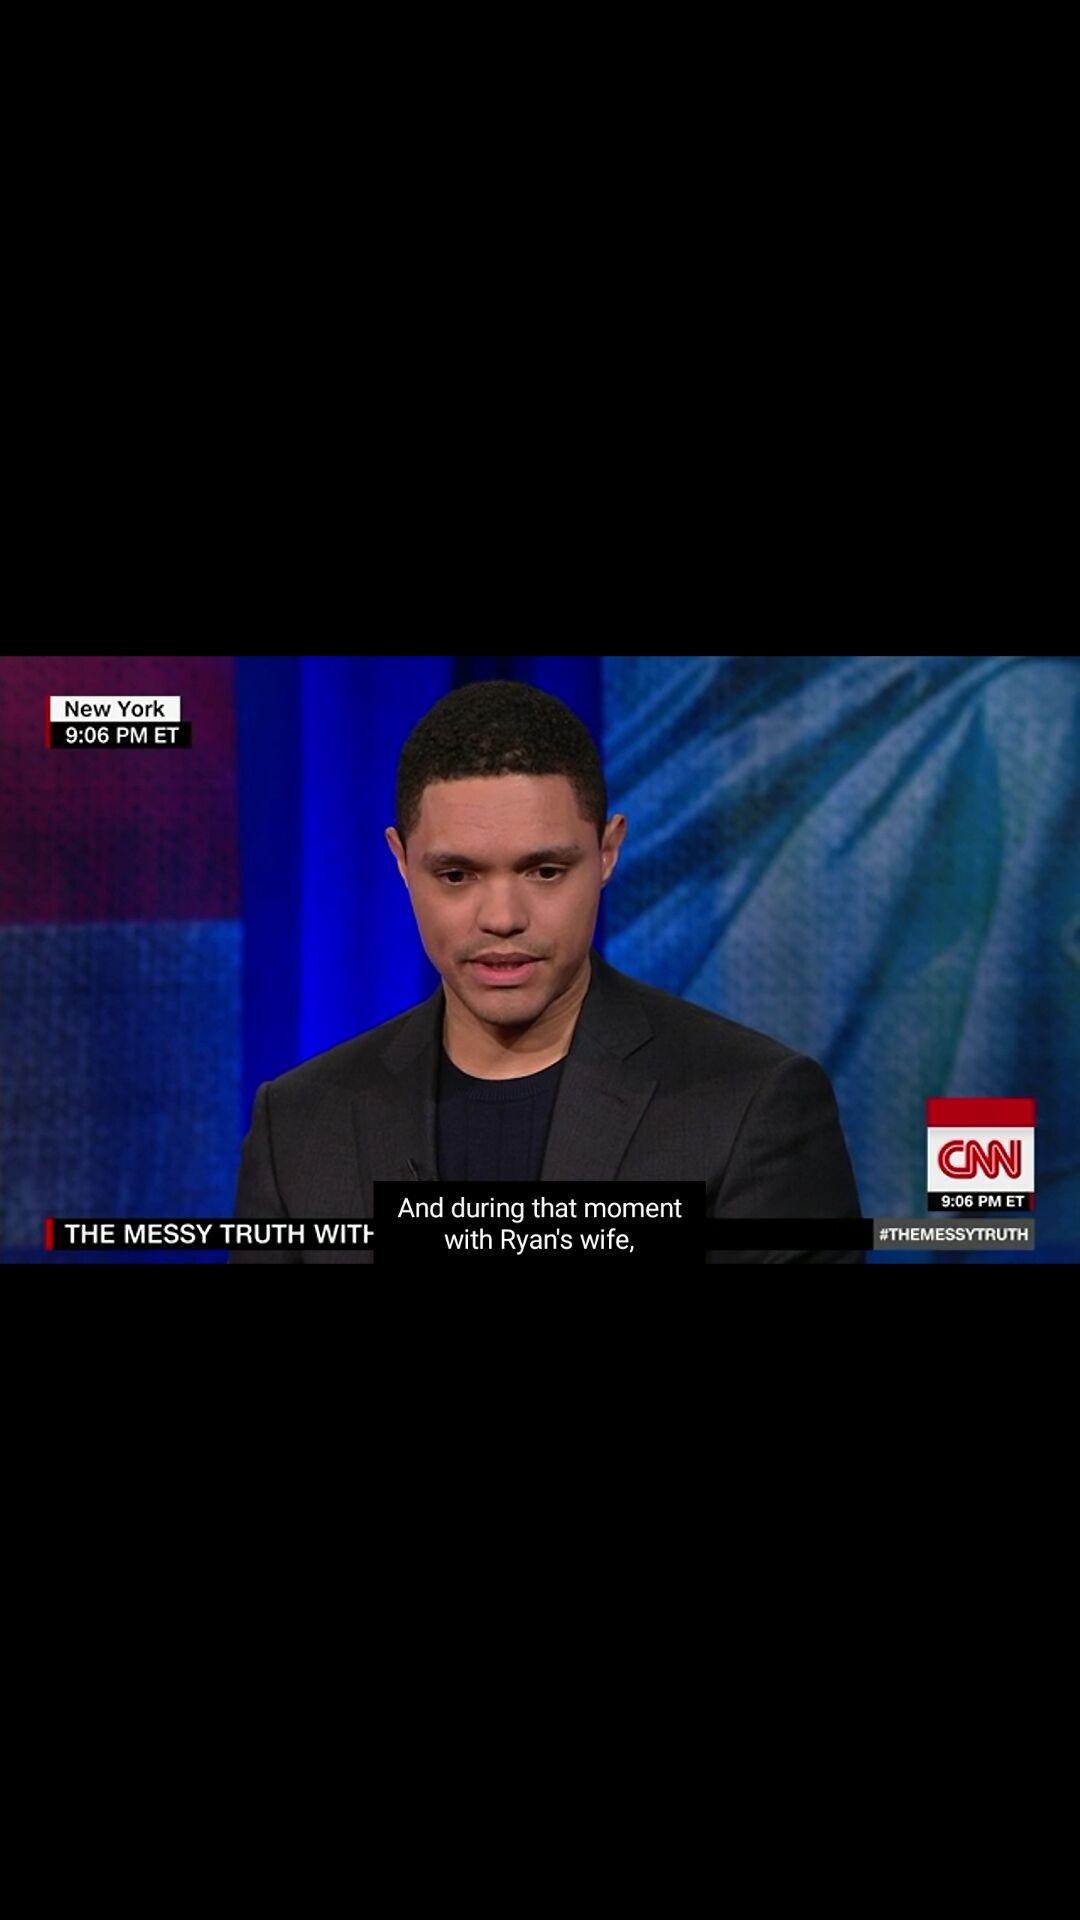What is the application name? The application name is "CNN". 